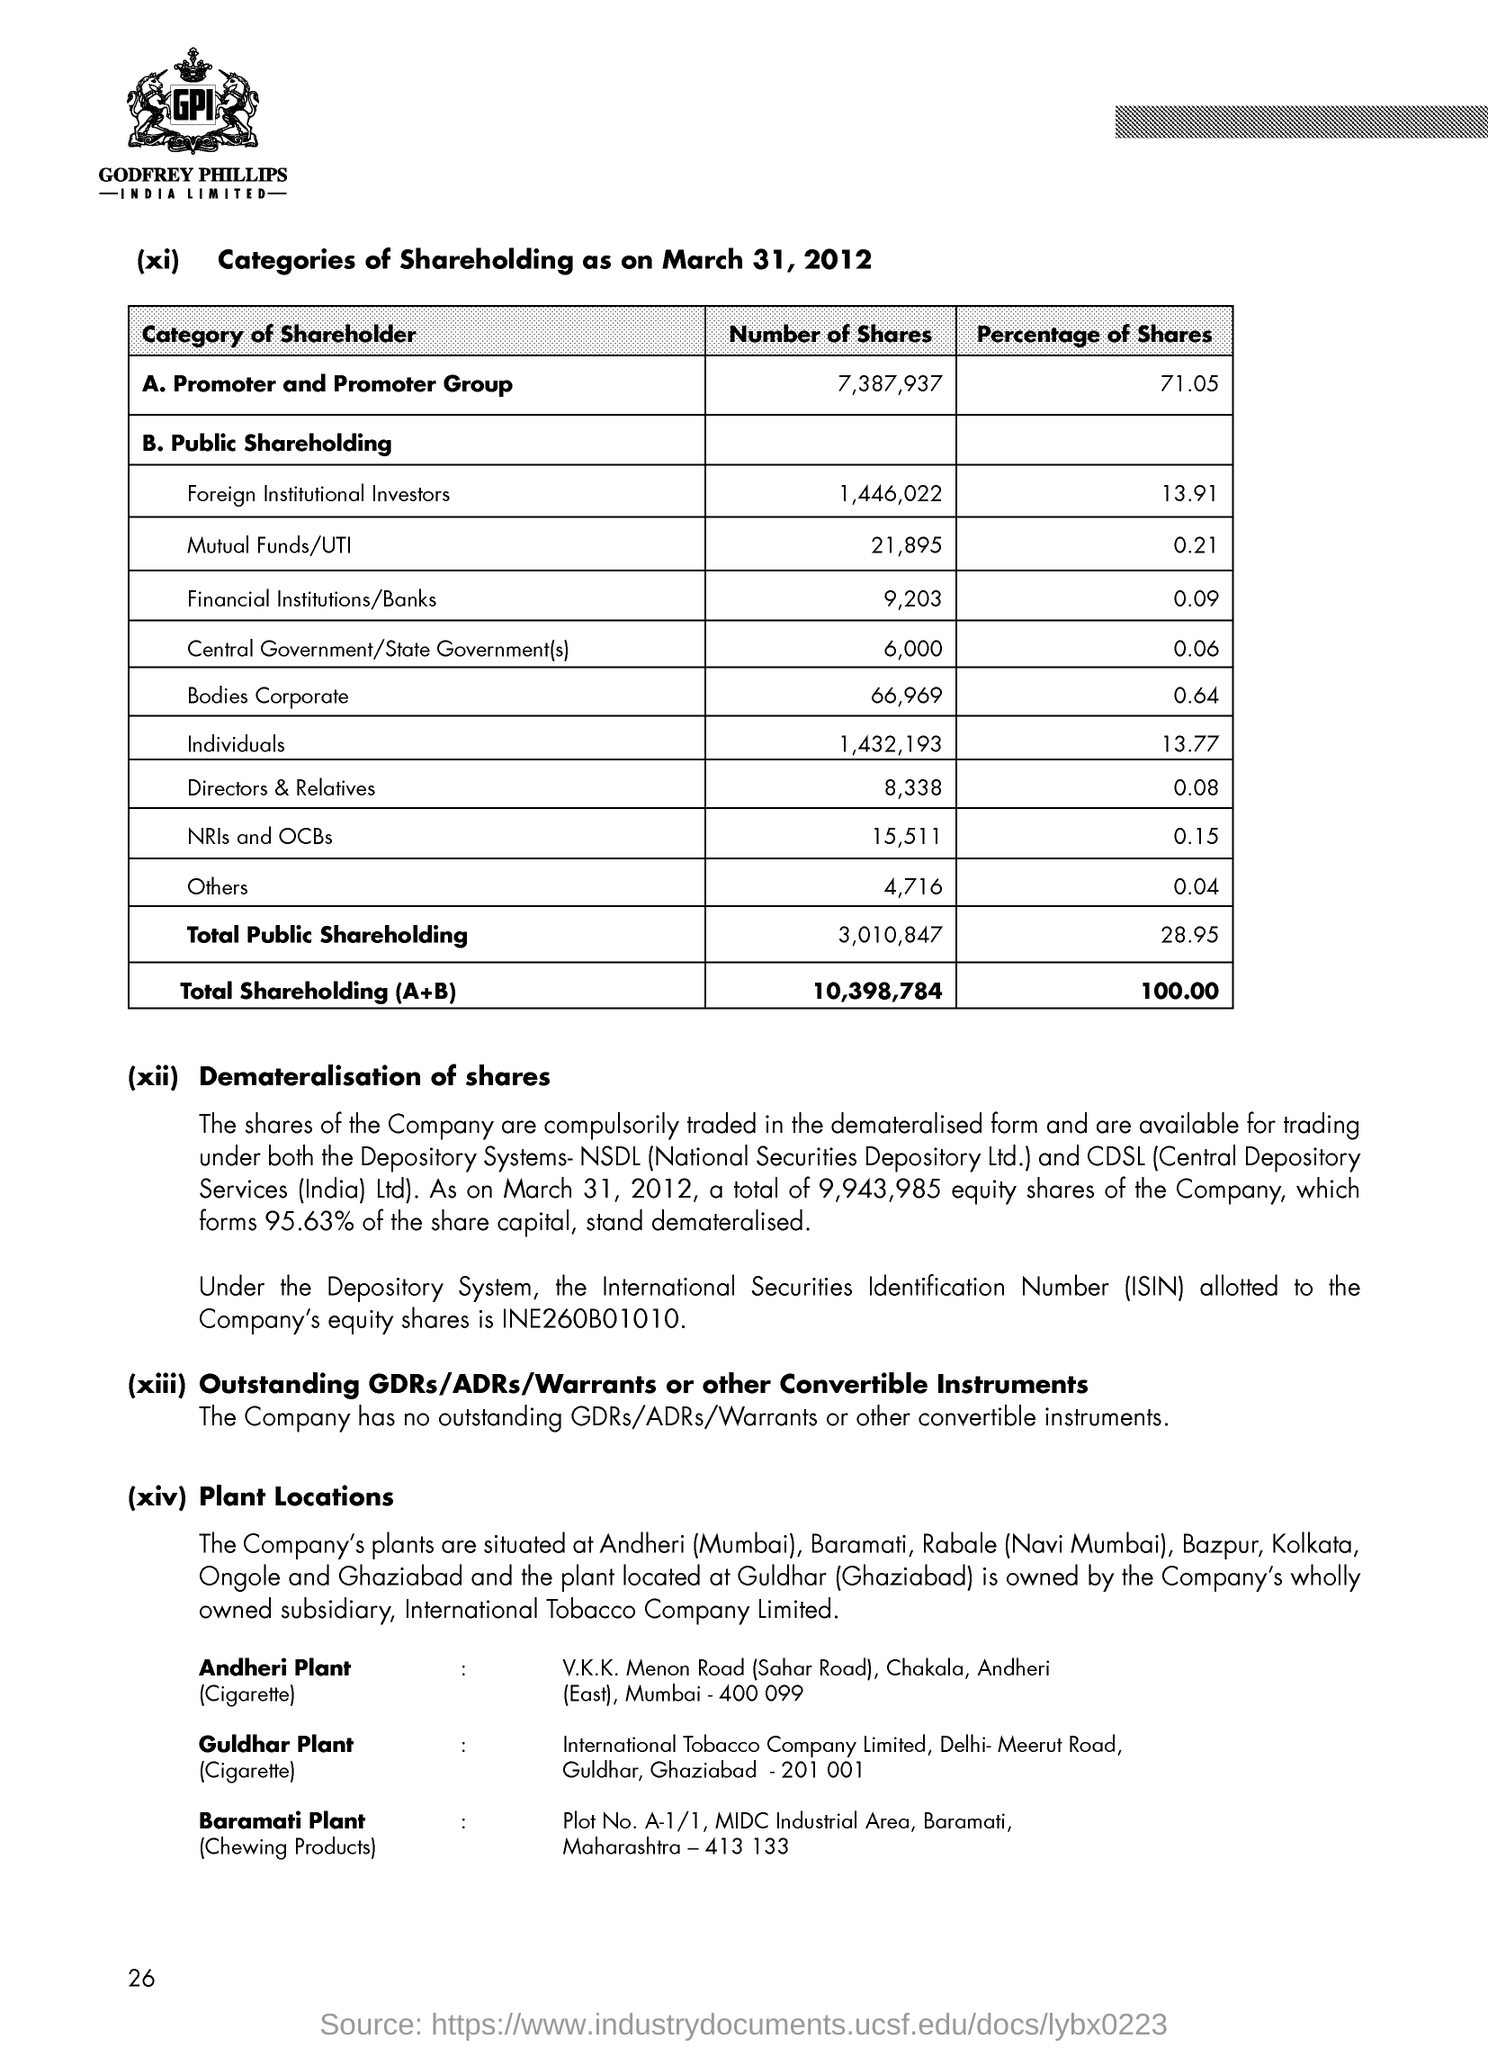Which company logo is present on the top?
Your answer should be compact. GODFREY PHILLIPS INDIA LIMITED. What is the Percentage of Shares for Individuals ?
Give a very brief answer. 13.77. 